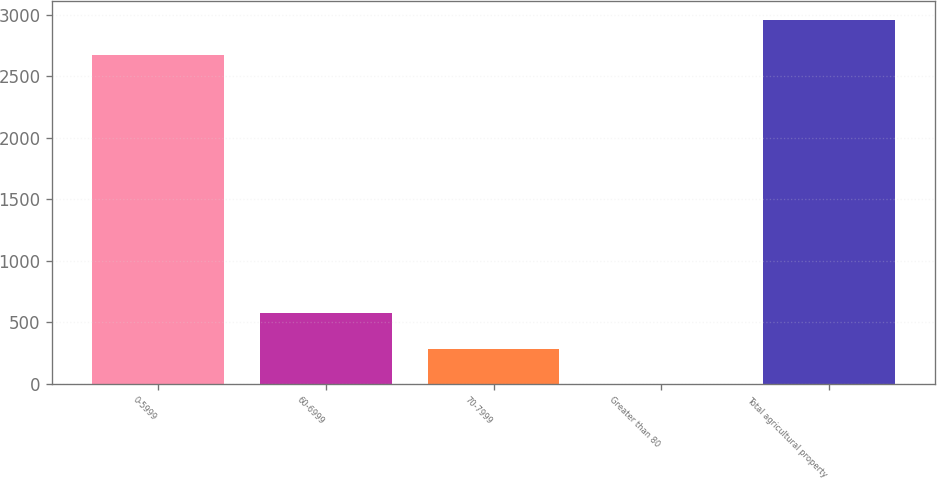Convert chart. <chart><loc_0><loc_0><loc_500><loc_500><bar_chart><fcel>0-5999<fcel>60-6999<fcel>70-7999<fcel>Greater than 80<fcel>Total agricultural property<nl><fcel>2674<fcel>572.48<fcel>286.66<fcel>0.84<fcel>2959.82<nl></chart> 